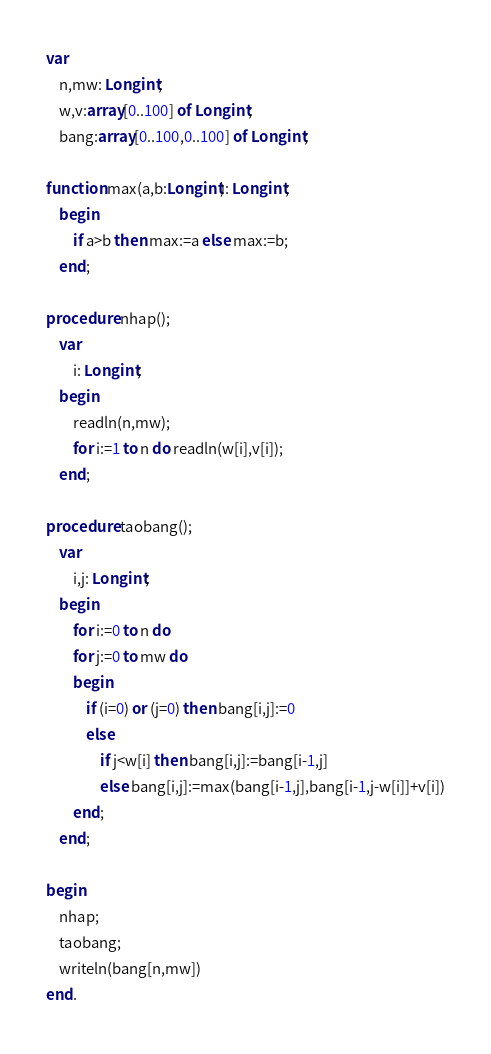Convert code to text. <code><loc_0><loc_0><loc_500><loc_500><_Pascal_>var
	n,mw: Longint;
	w,v:array[0..100] of Longint;
	bang:array[0..100,0..100] of Longint;

function max(a,b:Longint): Longint;
	begin
		if a>b then max:=a else max:=b;
	end;

procedure nhap();
	var
		i: Longint;
	begin
		readln(n,mw);
		for i:=1 to n do readln(w[i],v[i]);
	end;

procedure taobang();
	var
		i,j: Longint;
	begin
		for i:=0 to n do
		for j:=0 to mw do
		begin
			if (i=0) or (j=0) then bang[i,j]:=0
			else 
				if j<w[i] then bang[i,j]:=bang[i-1,j]
				else bang[i,j]:=max(bang[i-1,j],bang[i-1,j-w[i]]+v[i])
		end;
	end;

begin
	nhap;
	taobang;
	writeln(bang[n,mw])
end.</code> 